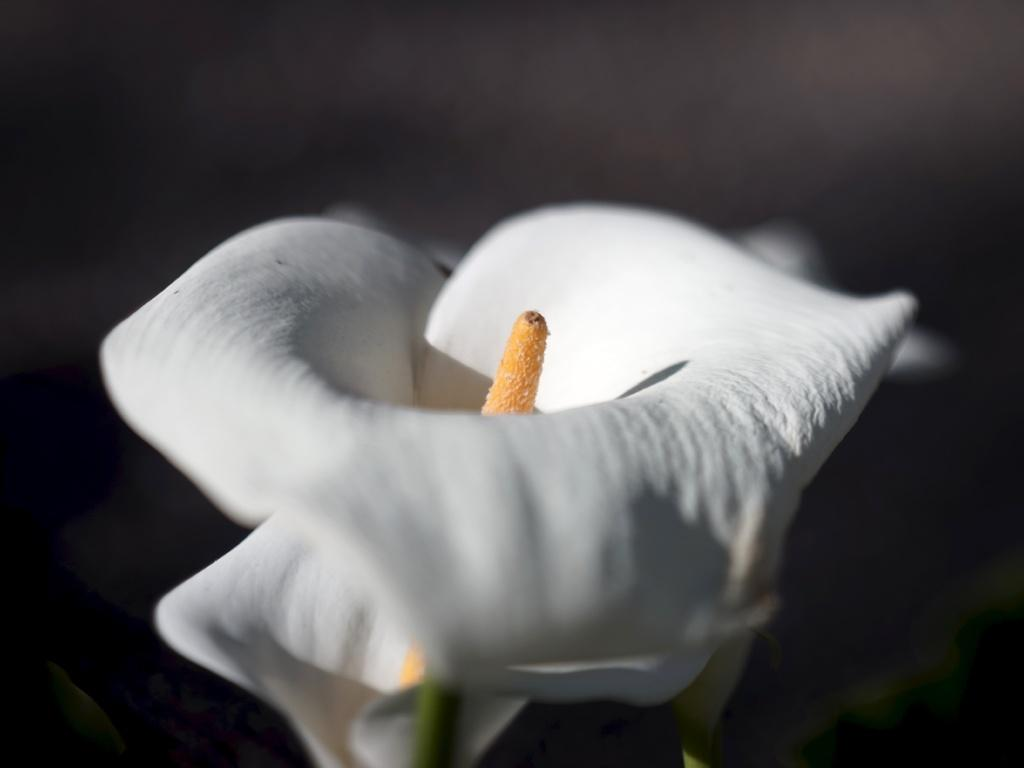What type of living organisms can be seen in the image? There are flowers in the image. Can you describe the background of the image? The background of the image is blurred. What type of mineral can be seen in the image? There is no mineral present in the image; it features flowers and a blurred background. What type of furniture is visible in the image? There is no furniture present in the image. 